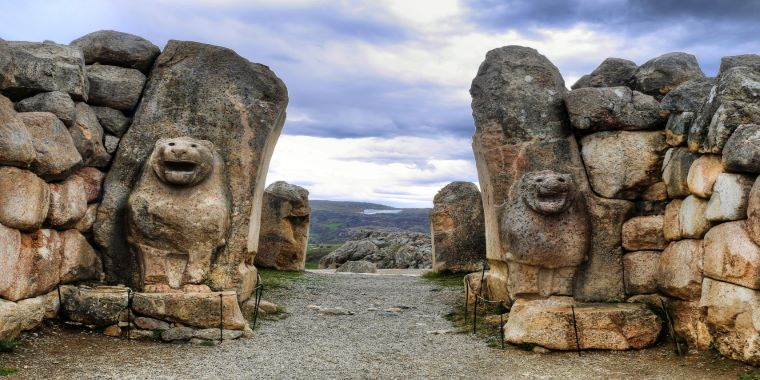Imagine and describe a day in the life of someone passing through the Lion Gate during the height of the Hittite Empire. The sun rises over the rugged Anatolian landscape, casting golden hues on the towering Lion Gate. A trader from a distant land approaches, leading a caravan of donkeys laden with precious goods—spices, textiles, and metals. As he passes the imposing lions, he feels a mix of awe and reassurance, knowing these stone sentinels have stood guard for centuries. The bustling activity inside the city greets him: craftsmen hammering away in their workshops, children playing along the streets, and priests conducting rituals in the nearby temples. The trader makes his way to the market square, eager to barter and share tales of his long journey. The Lions at the gate remind him of the city's grandeur and its importance as a hub of commerce and culture within the Hittite Empire. 